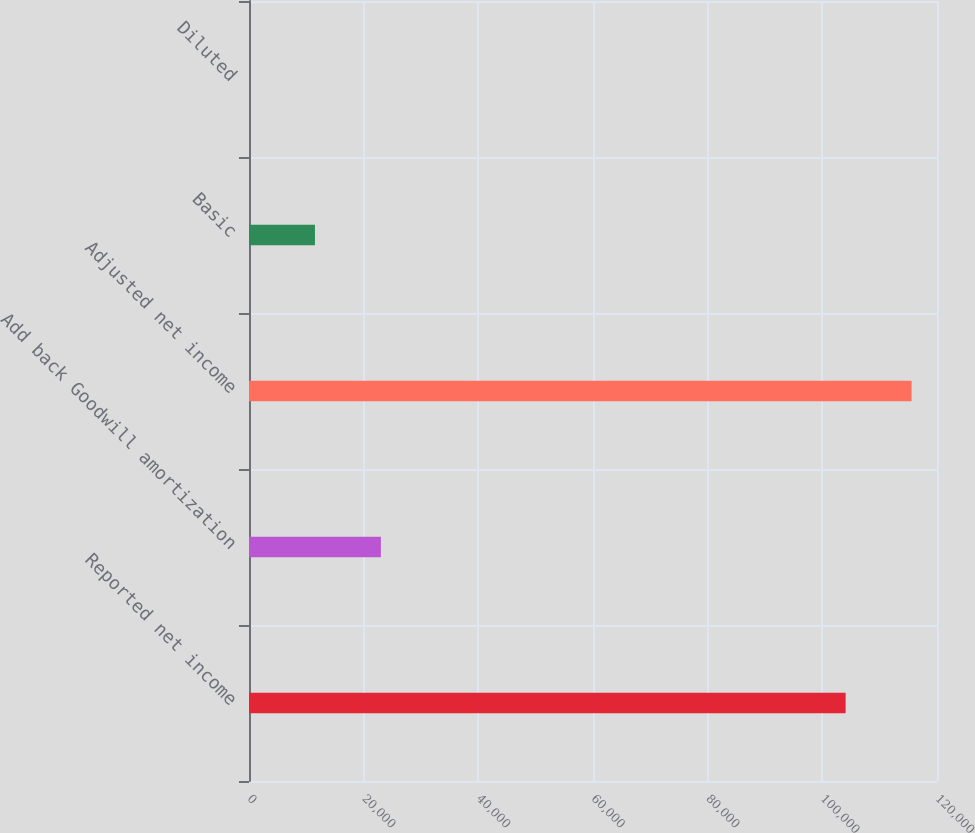<chart> <loc_0><loc_0><loc_500><loc_500><bar_chart><fcel>Reported net income<fcel>Add back Goodwill amortization<fcel>Adjusted net income<fcel>Basic<fcel>Diluted<nl><fcel>104063<fcel>23005.5<fcel>115565<fcel>11503.5<fcel>1.41<nl></chart> 